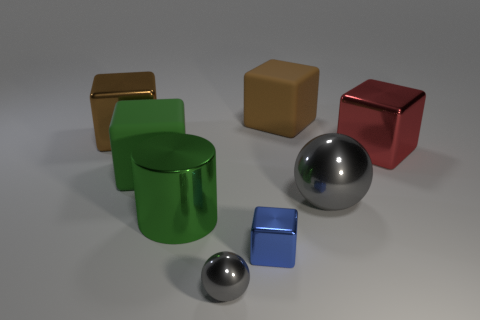Subtract all red blocks. How many blocks are left? 4 Subtract all tiny blue cubes. How many cubes are left? 4 Subtract 2 blocks. How many blocks are left? 3 Add 2 brown cubes. How many objects exist? 10 Subtract all green cubes. Subtract all gray spheres. How many cubes are left? 4 Subtract all blocks. How many objects are left? 3 Subtract 0 cyan blocks. How many objects are left? 8 Subtract all tiny cyan objects. Subtract all brown rubber things. How many objects are left? 7 Add 3 big green rubber objects. How many big green rubber objects are left? 4 Add 4 large matte things. How many large matte things exist? 6 